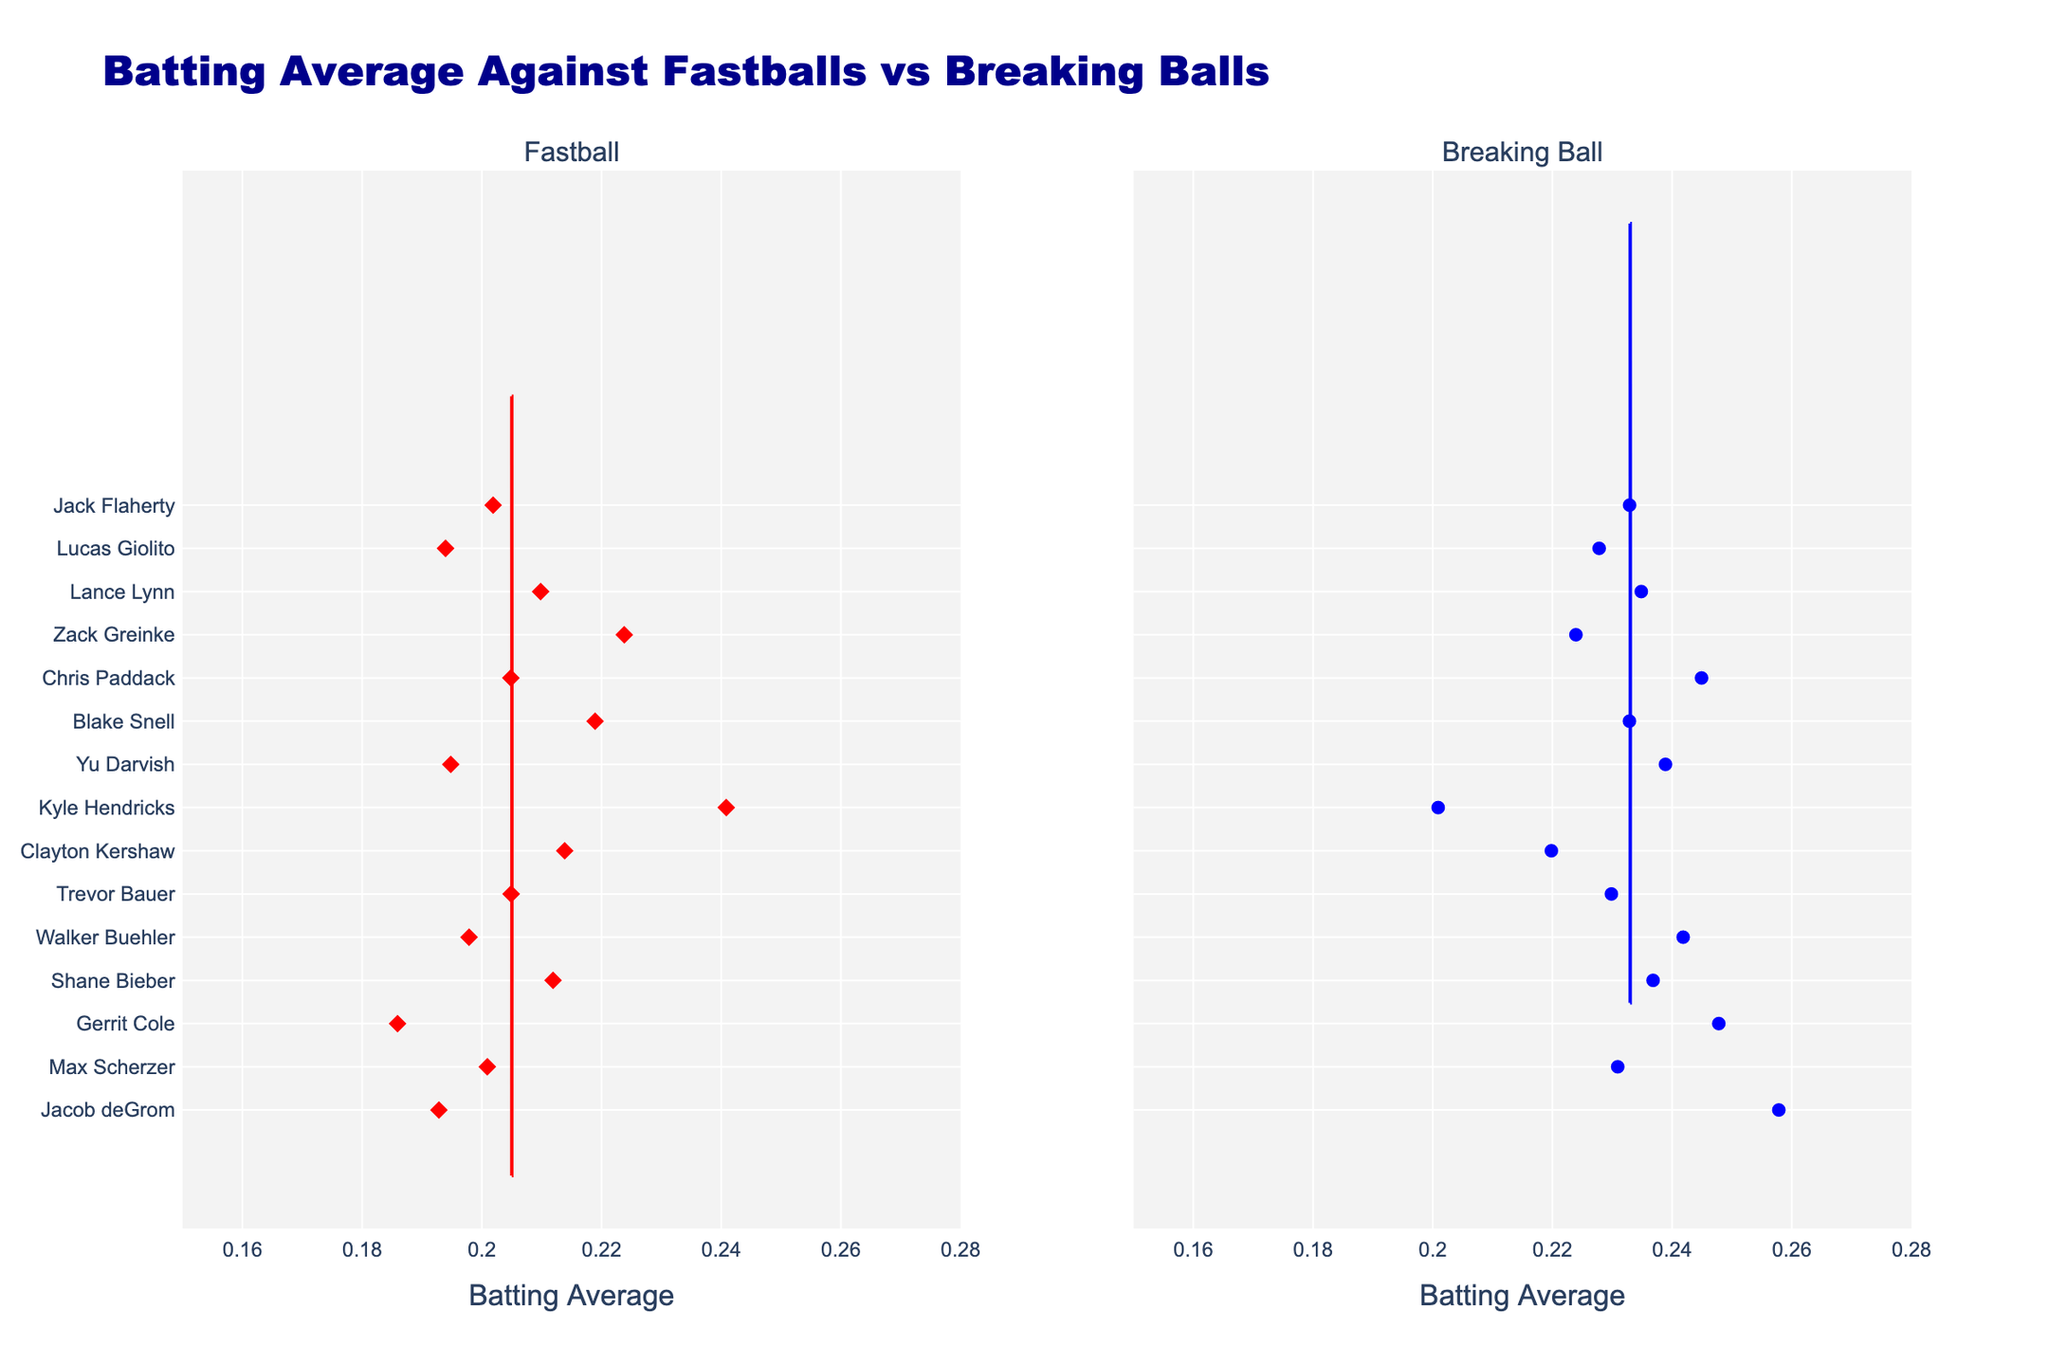What is the title of the chart? The title of the chart is located at the top and reads "Batting Average Against Fastballs vs Breaking Balls".
Answer: Batting Average Against Fastballs vs Breaking Balls How are the data points for Fastballs and Breaking Balls visually distinguished in the chart? The Fastballs are represented by red-colored symbols and the Breaking Balls are represented by blue-colored symbols, as indicated by their distinct colors and marker styles.
Answer: Red for Fastballs, Blue for Breaking Balls Which pitcher has the highest batting average against Fastballs? By examining the furthest right red marker in the Fastball section, we see that the furthest point belongs to Kyle Hendricks.
Answer: Kyle Hendricks Which pitcher has the lowest batting average against Breaking Balls? By looking at the furthest left blue marker in the Breaking Ball section, we find that Gerrit Cole has the lowest value.
Answer: Gerrit Cole Compare the batting averages of Trevor Bauer against Fastballs and Breaking Balls. Which is higher? We find Trevor Bauer's red and blue markers on the chart and compare their positions. The blue marker (Breaking Ball) is slightly to the left of the red marker (Fastball), indicating a higher average for Fastballs.
Answer: Fastballs What is the range of batting averages against Breaking Balls for all pitchers? The range can be established by looking at the left-most and right-most blue markers. The left-most value is approximately 0.201 and the right-most value is approximately 0.258. Therefore, the range is 0.201 to 0.258.
Answer: 0.201 to 0.258 Which pitcher has nearly identical averages for both Fastballs and Breaking Balls? We look for pitchers whose red and blue markers are at similar horizontal positions. Zack Greinke has both red and blue markers aligned at approximately the same position.
Answer: Zack Greinke What is the average batting average against Fastballs for all pitchers? We sum the batting averages for Fastballs and divide by the number of pitchers. (0.193 + 0.201 + 0.186 + 0.212 + 0.198 + 0.205 + 0.214 + 0.241 + 0.195 + 0.219 + 0.205 + 0.224 + 0.210 + 0.194 + 0.202) / 15 = 3.399 / 15 = 0.2266
Answer: 0.2266 Do more pitchers have a higher batting average against Fastballs or Breaking Balls? We count the number of blue markers positioned to the right of the corresponding red markers for each pitcher. Most pitchers’ blue markers are to the left indicating lower batting averages for Breaking Balls.
Answer: Breaking Balls 